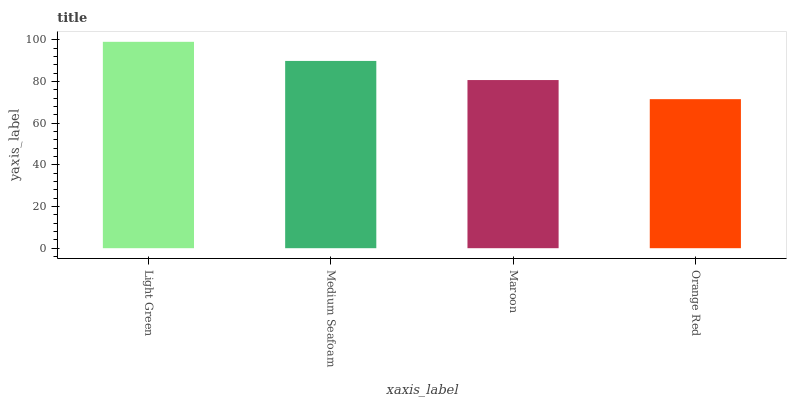Is Orange Red the minimum?
Answer yes or no. Yes. Is Light Green the maximum?
Answer yes or no. Yes. Is Medium Seafoam the minimum?
Answer yes or no. No. Is Medium Seafoam the maximum?
Answer yes or no. No. Is Light Green greater than Medium Seafoam?
Answer yes or no. Yes. Is Medium Seafoam less than Light Green?
Answer yes or no. Yes. Is Medium Seafoam greater than Light Green?
Answer yes or no. No. Is Light Green less than Medium Seafoam?
Answer yes or no. No. Is Medium Seafoam the high median?
Answer yes or no. Yes. Is Maroon the low median?
Answer yes or no. Yes. Is Light Green the high median?
Answer yes or no. No. Is Medium Seafoam the low median?
Answer yes or no. No. 